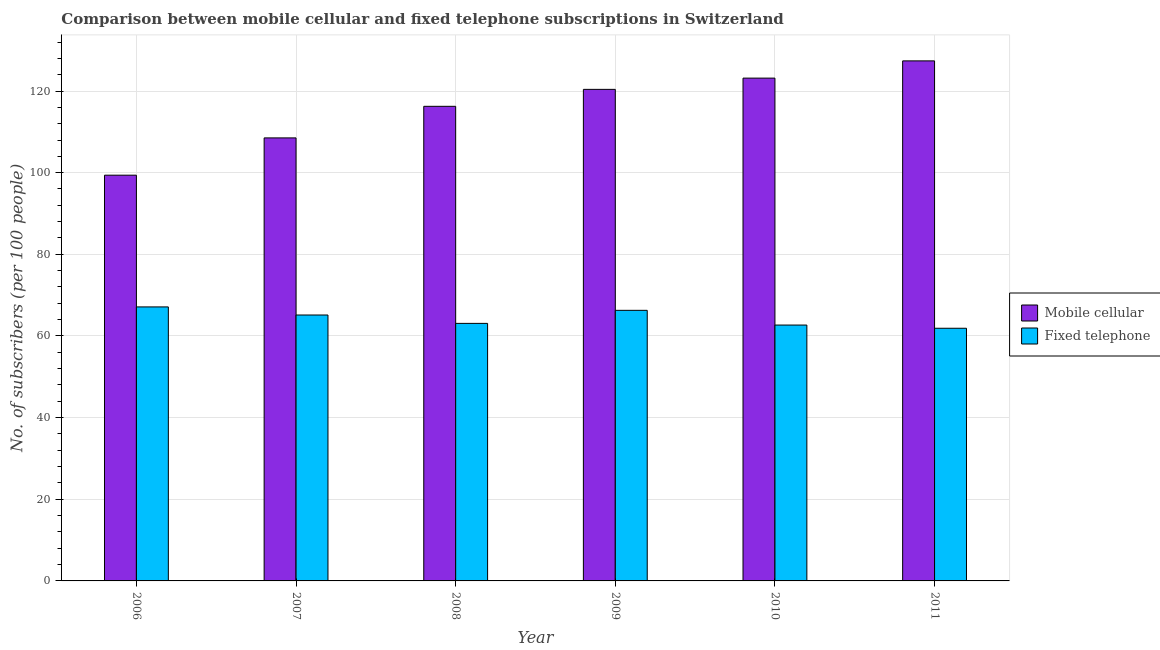How many different coloured bars are there?
Give a very brief answer. 2. How many groups of bars are there?
Provide a succinct answer. 6. How many bars are there on the 6th tick from the left?
Offer a terse response. 2. In how many cases, is the number of bars for a given year not equal to the number of legend labels?
Give a very brief answer. 0. What is the number of mobile cellular subscribers in 2006?
Make the answer very short. 99.39. Across all years, what is the maximum number of mobile cellular subscribers?
Your response must be concise. 127.38. Across all years, what is the minimum number of fixed telephone subscribers?
Your answer should be compact. 61.89. In which year was the number of mobile cellular subscribers maximum?
Give a very brief answer. 2011. What is the total number of fixed telephone subscribers in the graph?
Your answer should be compact. 386.18. What is the difference between the number of fixed telephone subscribers in 2010 and that in 2011?
Offer a terse response. 0.78. What is the difference between the number of fixed telephone subscribers in 2008 and the number of mobile cellular subscribers in 2010?
Provide a succinct answer. 0.41. What is the average number of mobile cellular subscribers per year?
Your answer should be very brief. 115.85. In how many years, is the number of mobile cellular subscribers greater than 128?
Ensure brevity in your answer.  0. What is the ratio of the number of mobile cellular subscribers in 2008 to that in 2010?
Keep it short and to the point. 0.94. Is the number of mobile cellular subscribers in 2008 less than that in 2009?
Keep it short and to the point. Yes. Is the difference between the number of fixed telephone subscribers in 2009 and 2010 greater than the difference between the number of mobile cellular subscribers in 2009 and 2010?
Ensure brevity in your answer.  No. What is the difference between the highest and the second highest number of fixed telephone subscribers?
Provide a short and direct response. 0.84. What is the difference between the highest and the lowest number of mobile cellular subscribers?
Keep it short and to the point. 28. What does the 1st bar from the left in 2007 represents?
Offer a terse response. Mobile cellular. What does the 1st bar from the right in 2010 represents?
Provide a short and direct response. Fixed telephone. How many bars are there?
Make the answer very short. 12. Are all the bars in the graph horizontal?
Offer a very short reply. No. How many years are there in the graph?
Give a very brief answer. 6. What is the difference between two consecutive major ticks on the Y-axis?
Offer a very short reply. 20. Are the values on the major ticks of Y-axis written in scientific E-notation?
Make the answer very short. No. Does the graph contain any zero values?
Provide a succinct answer. No. What is the title of the graph?
Offer a terse response. Comparison between mobile cellular and fixed telephone subscriptions in Switzerland. What is the label or title of the X-axis?
Keep it short and to the point. Year. What is the label or title of the Y-axis?
Provide a short and direct response. No. of subscribers (per 100 people). What is the No. of subscribers (per 100 people) of Mobile cellular in 2006?
Give a very brief answer. 99.39. What is the No. of subscribers (per 100 people) of Fixed telephone in 2006?
Your answer should be compact. 67.12. What is the No. of subscribers (per 100 people) in Mobile cellular in 2007?
Make the answer very short. 108.52. What is the No. of subscribers (per 100 people) of Fixed telephone in 2007?
Your answer should be very brief. 65.13. What is the No. of subscribers (per 100 people) of Mobile cellular in 2008?
Your answer should be compact. 116.25. What is the No. of subscribers (per 100 people) of Fixed telephone in 2008?
Make the answer very short. 63.08. What is the No. of subscribers (per 100 people) in Mobile cellular in 2009?
Offer a terse response. 120.4. What is the No. of subscribers (per 100 people) in Fixed telephone in 2009?
Ensure brevity in your answer.  66.28. What is the No. of subscribers (per 100 people) in Mobile cellular in 2010?
Your answer should be very brief. 123.16. What is the No. of subscribers (per 100 people) of Fixed telephone in 2010?
Provide a succinct answer. 62.67. What is the No. of subscribers (per 100 people) in Mobile cellular in 2011?
Keep it short and to the point. 127.38. What is the No. of subscribers (per 100 people) in Fixed telephone in 2011?
Offer a terse response. 61.89. Across all years, what is the maximum No. of subscribers (per 100 people) in Mobile cellular?
Ensure brevity in your answer.  127.38. Across all years, what is the maximum No. of subscribers (per 100 people) of Fixed telephone?
Offer a very short reply. 67.12. Across all years, what is the minimum No. of subscribers (per 100 people) in Mobile cellular?
Ensure brevity in your answer.  99.39. Across all years, what is the minimum No. of subscribers (per 100 people) of Fixed telephone?
Your answer should be very brief. 61.89. What is the total No. of subscribers (per 100 people) of Mobile cellular in the graph?
Your response must be concise. 695.1. What is the total No. of subscribers (per 100 people) in Fixed telephone in the graph?
Offer a terse response. 386.18. What is the difference between the No. of subscribers (per 100 people) in Mobile cellular in 2006 and that in 2007?
Give a very brief answer. -9.13. What is the difference between the No. of subscribers (per 100 people) of Fixed telephone in 2006 and that in 2007?
Offer a terse response. 1.98. What is the difference between the No. of subscribers (per 100 people) in Mobile cellular in 2006 and that in 2008?
Keep it short and to the point. -16.87. What is the difference between the No. of subscribers (per 100 people) of Fixed telephone in 2006 and that in 2008?
Give a very brief answer. 4.03. What is the difference between the No. of subscribers (per 100 people) in Mobile cellular in 2006 and that in 2009?
Ensure brevity in your answer.  -21.02. What is the difference between the No. of subscribers (per 100 people) in Fixed telephone in 2006 and that in 2009?
Give a very brief answer. 0.84. What is the difference between the No. of subscribers (per 100 people) of Mobile cellular in 2006 and that in 2010?
Your response must be concise. -23.78. What is the difference between the No. of subscribers (per 100 people) in Fixed telephone in 2006 and that in 2010?
Your response must be concise. 4.44. What is the difference between the No. of subscribers (per 100 people) of Mobile cellular in 2006 and that in 2011?
Make the answer very short. -28. What is the difference between the No. of subscribers (per 100 people) in Fixed telephone in 2006 and that in 2011?
Provide a short and direct response. 5.23. What is the difference between the No. of subscribers (per 100 people) in Mobile cellular in 2007 and that in 2008?
Your response must be concise. -7.73. What is the difference between the No. of subscribers (per 100 people) of Fixed telephone in 2007 and that in 2008?
Your answer should be very brief. 2.05. What is the difference between the No. of subscribers (per 100 people) in Mobile cellular in 2007 and that in 2009?
Ensure brevity in your answer.  -11.89. What is the difference between the No. of subscribers (per 100 people) of Fixed telephone in 2007 and that in 2009?
Your answer should be very brief. -1.15. What is the difference between the No. of subscribers (per 100 people) in Mobile cellular in 2007 and that in 2010?
Offer a terse response. -14.65. What is the difference between the No. of subscribers (per 100 people) in Fixed telephone in 2007 and that in 2010?
Offer a terse response. 2.46. What is the difference between the No. of subscribers (per 100 people) in Mobile cellular in 2007 and that in 2011?
Provide a short and direct response. -18.87. What is the difference between the No. of subscribers (per 100 people) in Fixed telephone in 2007 and that in 2011?
Ensure brevity in your answer.  3.24. What is the difference between the No. of subscribers (per 100 people) of Mobile cellular in 2008 and that in 2009?
Provide a succinct answer. -4.15. What is the difference between the No. of subscribers (per 100 people) in Fixed telephone in 2008 and that in 2009?
Make the answer very short. -3.19. What is the difference between the No. of subscribers (per 100 people) of Mobile cellular in 2008 and that in 2010?
Your answer should be compact. -6.91. What is the difference between the No. of subscribers (per 100 people) of Fixed telephone in 2008 and that in 2010?
Keep it short and to the point. 0.41. What is the difference between the No. of subscribers (per 100 people) in Mobile cellular in 2008 and that in 2011?
Offer a terse response. -11.13. What is the difference between the No. of subscribers (per 100 people) in Fixed telephone in 2008 and that in 2011?
Give a very brief answer. 1.19. What is the difference between the No. of subscribers (per 100 people) of Mobile cellular in 2009 and that in 2010?
Provide a succinct answer. -2.76. What is the difference between the No. of subscribers (per 100 people) of Fixed telephone in 2009 and that in 2010?
Your answer should be compact. 3.6. What is the difference between the No. of subscribers (per 100 people) in Mobile cellular in 2009 and that in 2011?
Provide a short and direct response. -6.98. What is the difference between the No. of subscribers (per 100 people) of Fixed telephone in 2009 and that in 2011?
Your response must be concise. 4.39. What is the difference between the No. of subscribers (per 100 people) in Mobile cellular in 2010 and that in 2011?
Give a very brief answer. -4.22. What is the difference between the No. of subscribers (per 100 people) of Fixed telephone in 2010 and that in 2011?
Your answer should be compact. 0.78. What is the difference between the No. of subscribers (per 100 people) in Mobile cellular in 2006 and the No. of subscribers (per 100 people) in Fixed telephone in 2007?
Keep it short and to the point. 34.25. What is the difference between the No. of subscribers (per 100 people) in Mobile cellular in 2006 and the No. of subscribers (per 100 people) in Fixed telephone in 2008?
Provide a succinct answer. 36.3. What is the difference between the No. of subscribers (per 100 people) in Mobile cellular in 2006 and the No. of subscribers (per 100 people) in Fixed telephone in 2009?
Offer a terse response. 33.11. What is the difference between the No. of subscribers (per 100 people) of Mobile cellular in 2006 and the No. of subscribers (per 100 people) of Fixed telephone in 2010?
Give a very brief answer. 36.71. What is the difference between the No. of subscribers (per 100 people) in Mobile cellular in 2006 and the No. of subscribers (per 100 people) in Fixed telephone in 2011?
Make the answer very short. 37.49. What is the difference between the No. of subscribers (per 100 people) of Mobile cellular in 2007 and the No. of subscribers (per 100 people) of Fixed telephone in 2008?
Provide a short and direct response. 45.43. What is the difference between the No. of subscribers (per 100 people) in Mobile cellular in 2007 and the No. of subscribers (per 100 people) in Fixed telephone in 2009?
Your answer should be compact. 42.24. What is the difference between the No. of subscribers (per 100 people) in Mobile cellular in 2007 and the No. of subscribers (per 100 people) in Fixed telephone in 2010?
Offer a very short reply. 45.84. What is the difference between the No. of subscribers (per 100 people) in Mobile cellular in 2007 and the No. of subscribers (per 100 people) in Fixed telephone in 2011?
Your answer should be very brief. 46.62. What is the difference between the No. of subscribers (per 100 people) in Mobile cellular in 2008 and the No. of subscribers (per 100 people) in Fixed telephone in 2009?
Provide a succinct answer. 49.97. What is the difference between the No. of subscribers (per 100 people) in Mobile cellular in 2008 and the No. of subscribers (per 100 people) in Fixed telephone in 2010?
Make the answer very short. 53.58. What is the difference between the No. of subscribers (per 100 people) of Mobile cellular in 2008 and the No. of subscribers (per 100 people) of Fixed telephone in 2011?
Provide a short and direct response. 54.36. What is the difference between the No. of subscribers (per 100 people) of Mobile cellular in 2009 and the No. of subscribers (per 100 people) of Fixed telephone in 2010?
Provide a short and direct response. 57.73. What is the difference between the No. of subscribers (per 100 people) in Mobile cellular in 2009 and the No. of subscribers (per 100 people) in Fixed telephone in 2011?
Provide a succinct answer. 58.51. What is the difference between the No. of subscribers (per 100 people) in Mobile cellular in 2010 and the No. of subscribers (per 100 people) in Fixed telephone in 2011?
Offer a terse response. 61.27. What is the average No. of subscribers (per 100 people) in Mobile cellular per year?
Provide a short and direct response. 115.85. What is the average No. of subscribers (per 100 people) in Fixed telephone per year?
Ensure brevity in your answer.  64.36. In the year 2006, what is the difference between the No. of subscribers (per 100 people) in Mobile cellular and No. of subscribers (per 100 people) in Fixed telephone?
Ensure brevity in your answer.  32.27. In the year 2007, what is the difference between the No. of subscribers (per 100 people) of Mobile cellular and No. of subscribers (per 100 people) of Fixed telephone?
Offer a terse response. 43.38. In the year 2008, what is the difference between the No. of subscribers (per 100 people) of Mobile cellular and No. of subscribers (per 100 people) of Fixed telephone?
Give a very brief answer. 53.17. In the year 2009, what is the difference between the No. of subscribers (per 100 people) of Mobile cellular and No. of subscribers (per 100 people) of Fixed telephone?
Your response must be concise. 54.12. In the year 2010, what is the difference between the No. of subscribers (per 100 people) in Mobile cellular and No. of subscribers (per 100 people) in Fixed telephone?
Provide a short and direct response. 60.49. In the year 2011, what is the difference between the No. of subscribers (per 100 people) of Mobile cellular and No. of subscribers (per 100 people) of Fixed telephone?
Your answer should be very brief. 65.49. What is the ratio of the No. of subscribers (per 100 people) in Mobile cellular in 2006 to that in 2007?
Keep it short and to the point. 0.92. What is the ratio of the No. of subscribers (per 100 people) of Fixed telephone in 2006 to that in 2007?
Ensure brevity in your answer.  1.03. What is the ratio of the No. of subscribers (per 100 people) of Mobile cellular in 2006 to that in 2008?
Ensure brevity in your answer.  0.85. What is the ratio of the No. of subscribers (per 100 people) in Fixed telephone in 2006 to that in 2008?
Provide a succinct answer. 1.06. What is the ratio of the No. of subscribers (per 100 people) in Mobile cellular in 2006 to that in 2009?
Your response must be concise. 0.83. What is the ratio of the No. of subscribers (per 100 people) in Fixed telephone in 2006 to that in 2009?
Provide a succinct answer. 1.01. What is the ratio of the No. of subscribers (per 100 people) in Mobile cellular in 2006 to that in 2010?
Ensure brevity in your answer.  0.81. What is the ratio of the No. of subscribers (per 100 people) of Fixed telephone in 2006 to that in 2010?
Provide a short and direct response. 1.07. What is the ratio of the No. of subscribers (per 100 people) of Mobile cellular in 2006 to that in 2011?
Your answer should be compact. 0.78. What is the ratio of the No. of subscribers (per 100 people) of Fixed telephone in 2006 to that in 2011?
Offer a terse response. 1.08. What is the ratio of the No. of subscribers (per 100 people) in Mobile cellular in 2007 to that in 2008?
Ensure brevity in your answer.  0.93. What is the ratio of the No. of subscribers (per 100 people) in Fixed telephone in 2007 to that in 2008?
Provide a succinct answer. 1.03. What is the ratio of the No. of subscribers (per 100 people) of Mobile cellular in 2007 to that in 2009?
Provide a short and direct response. 0.9. What is the ratio of the No. of subscribers (per 100 people) in Fixed telephone in 2007 to that in 2009?
Offer a terse response. 0.98. What is the ratio of the No. of subscribers (per 100 people) of Mobile cellular in 2007 to that in 2010?
Ensure brevity in your answer.  0.88. What is the ratio of the No. of subscribers (per 100 people) in Fixed telephone in 2007 to that in 2010?
Your response must be concise. 1.04. What is the ratio of the No. of subscribers (per 100 people) in Mobile cellular in 2007 to that in 2011?
Your response must be concise. 0.85. What is the ratio of the No. of subscribers (per 100 people) in Fixed telephone in 2007 to that in 2011?
Make the answer very short. 1.05. What is the ratio of the No. of subscribers (per 100 people) of Mobile cellular in 2008 to that in 2009?
Give a very brief answer. 0.97. What is the ratio of the No. of subscribers (per 100 people) in Fixed telephone in 2008 to that in 2009?
Give a very brief answer. 0.95. What is the ratio of the No. of subscribers (per 100 people) in Mobile cellular in 2008 to that in 2010?
Make the answer very short. 0.94. What is the ratio of the No. of subscribers (per 100 people) of Mobile cellular in 2008 to that in 2011?
Offer a very short reply. 0.91. What is the ratio of the No. of subscribers (per 100 people) in Fixed telephone in 2008 to that in 2011?
Keep it short and to the point. 1.02. What is the ratio of the No. of subscribers (per 100 people) in Mobile cellular in 2009 to that in 2010?
Your answer should be very brief. 0.98. What is the ratio of the No. of subscribers (per 100 people) of Fixed telephone in 2009 to that in 2010?
Provide a succinct answer. 1.06. What is the ratio of the No. of subscribers (per 100 people) in Mobile cellular in 2009 to that in 2011?
Your response must be concise. 0.95. What is the ratio of the No. of subscribers (per 100 people) of Fixed telephone in 2009 to that in 2011?
Provide a short and direct response. 1.07. What is the ratio of the No. of subscribers (per 100 people) in Mobile cellular in 2010 to that in 2011?
Ensure brevity in your answer.  0.97. What is the ratio of the No. of subscribers (per 100 people) in Fixed telephone in 2010 to that in 2011?
Make the answer very short. 1.01. What is the difference between the highest and the second highest No. of subscribers (per 100 people) of Mobile cellular?
Your answer should be very brief. 4.22. What is the difference between the highest and the second highest No. of subscribers (per 100 people) in Fixed telephone?
Your answer should be very brief. 0.84. What is the difference between the highest and the lowest No. of subscribers (per 100 people) of Mobile cellular?
Offer a very short reply. 28. What is the difference between the highest and the lowest No. of subscribers (per 100 people) of Fixed telephone?
Offer a terse response. 5.23. 